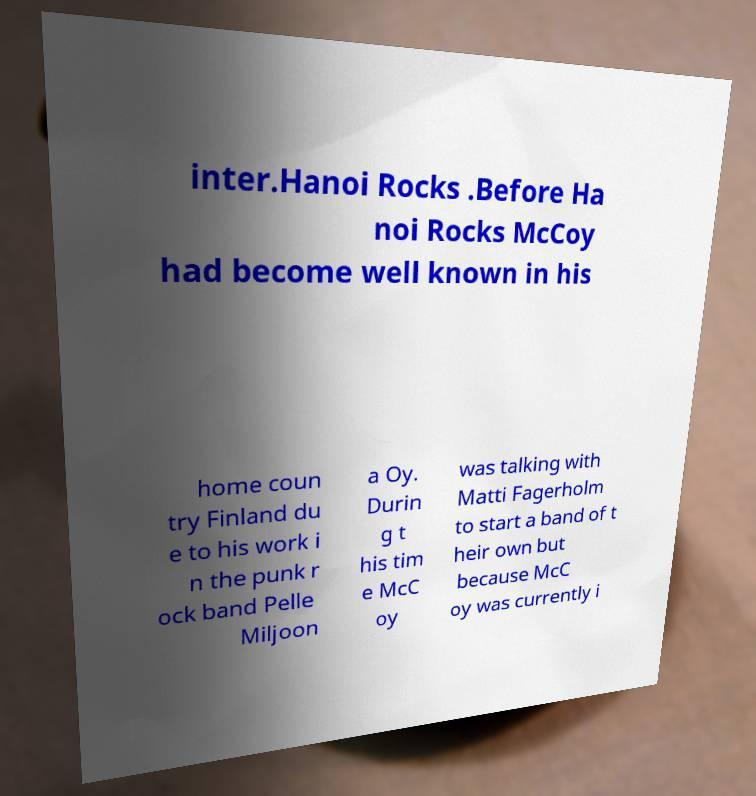Could you extract and type out the text from this image? inter.Hanoi Rocks .Before Ha noi Rocks McCoy had become well known in his home coun try Finland du e to his work i n the punk r ock band Pelle Miljoon a Oy. Durin g t his tim e McC oy was talking with Matti Fagerholm to start a band of t heir own but because McC oy was currently i 